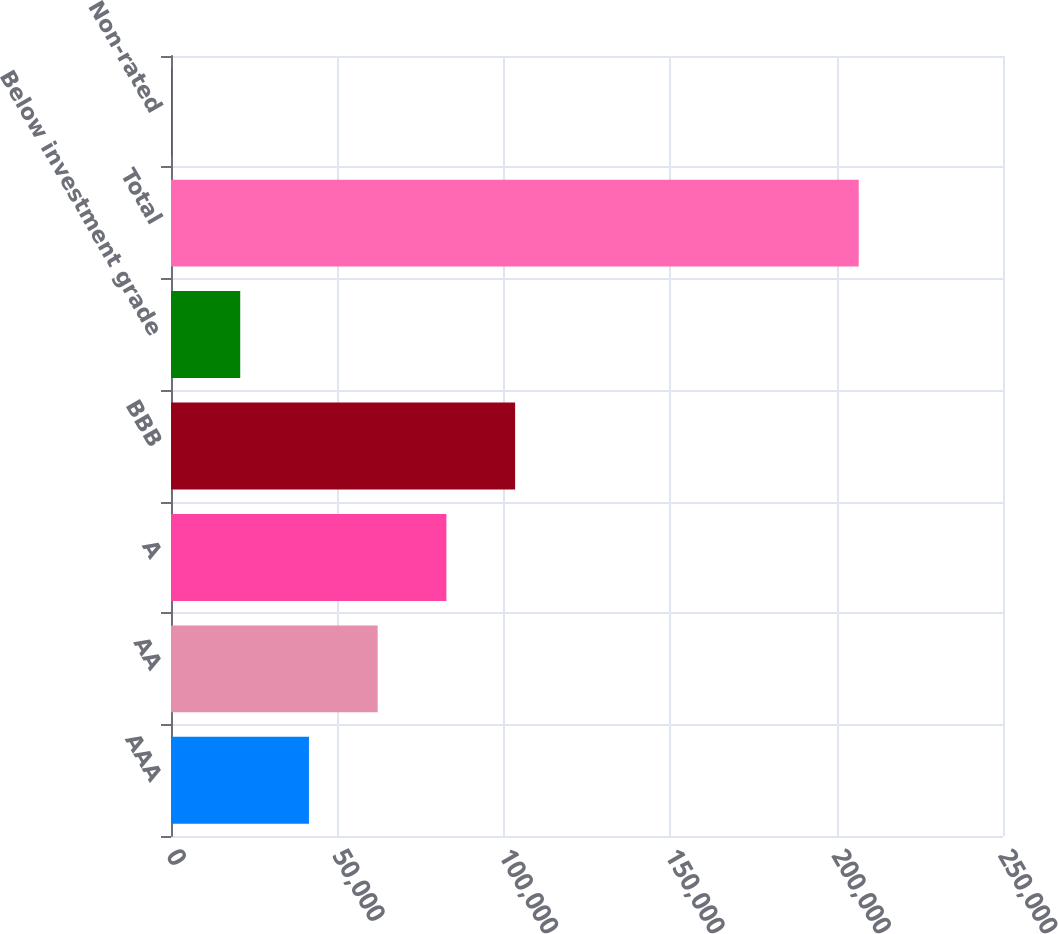Convert chart to OTSL. <chart><loc_0><loc_0><loc_500><loc_500><bar_chart><fcel>AAA<fcel>AA<fcel>A<fcel>BBB<fcel>Below investment grade<fcel>Total<fcel>Non-rated<nl><fcel>41449.4<fcel>62099.6<fcel>82749.8<fcel>103400<fcel>20799.2<fcel>206651<fcel>149<nl></chart> 